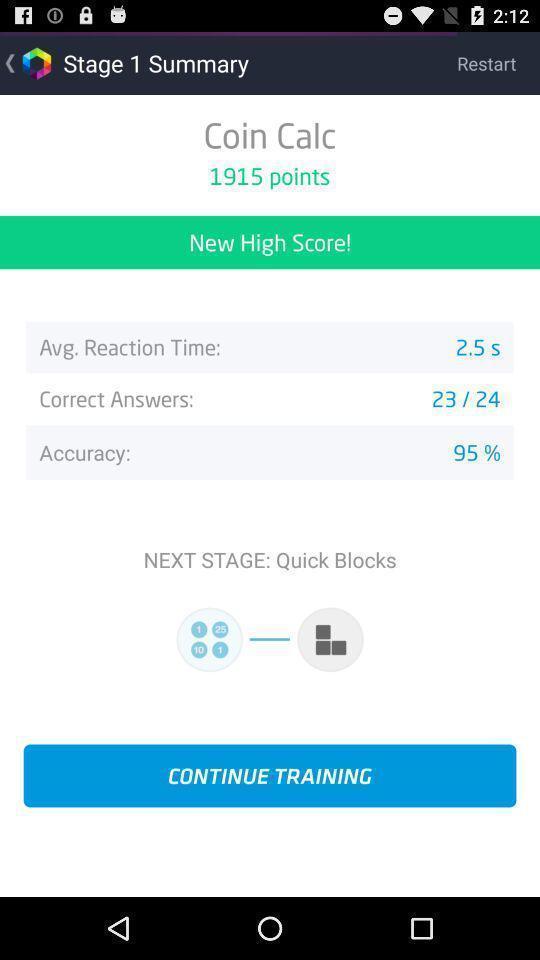Summarize the information in this screenshot. Screen shows stage 1 summary details. 